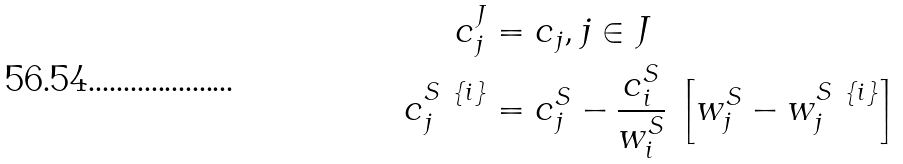<formula> <loc_0><loc_0><loc_500><loc_500>c ^ { J } _ { j } & = c _ { j } , j \in J \\ c ^ { S \ \{ i \} } _ { j } & = c ^ { S } _ { j } - \frac { c _ { i } ^ { S } } { w _ { i } ^ { S } } \, \left [ w ^ { S } _ { j } - w ^ { S \ \{ i \} } _ { j } \right ]</formula> 